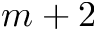<formula> <loc_0><loc_0><loc_500><loc_500>m + 2</formula> 